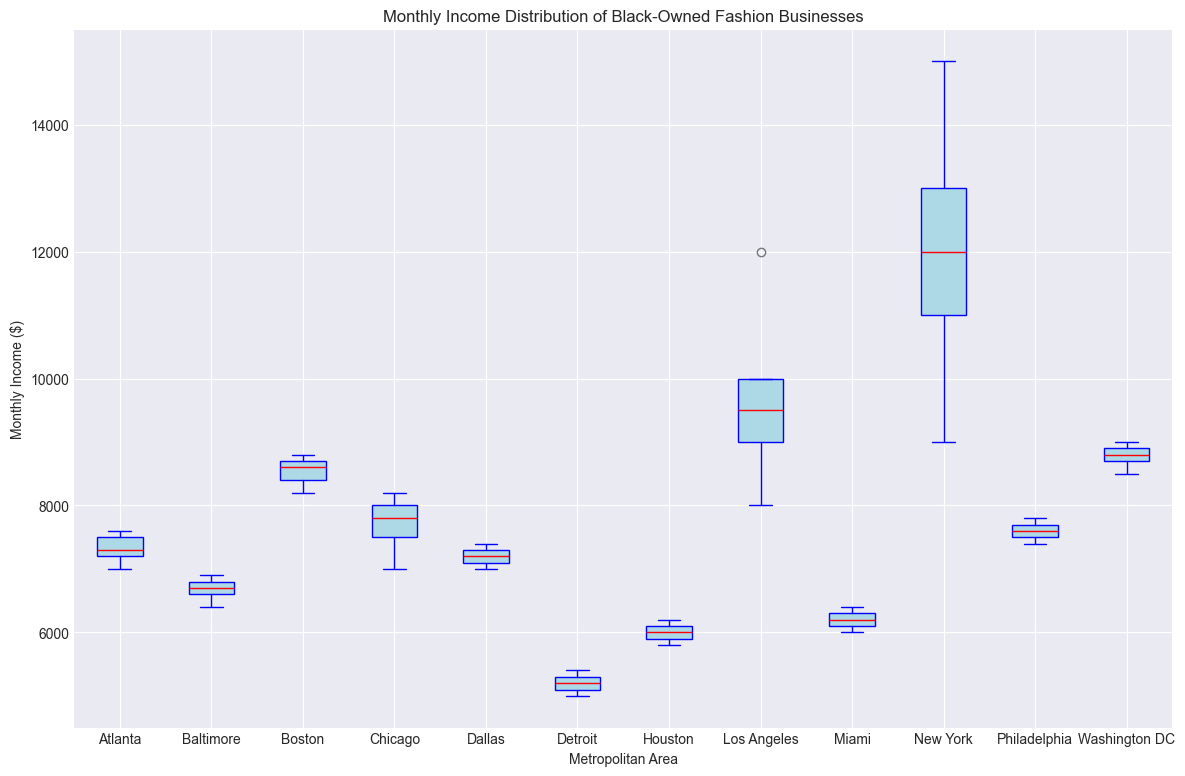Which metropolitan area has the highest median monthly income for black-owned fashion businesses? The box plot displays the median with a red line. By examining the red lines on the box plots, New York's median income appears to be the highest among the areas considered.
Answer: New York Which metropolitan area has the lowest median monthly income for black-owned fashion businesses? Looking at the box plot, Detroit has the lowest median monthly income, as indicated by its red line situated low compared to other cities.
Answer: Detroit What is the approximate interquartile range (IQR) for Los Angeles? The interquartile range (IQR) is the difference between the upper quartile (Q3) and the lower quartile (Q1). For Los Angeles, this range can be identified by measuring the length of the box from the top to the bottom. It seems to be from about $9,000 to $12,000, so the IQR is approximately 12,000 - 9,000 = 3,000.
Answer: 3,000 Which metropolitan area has the widest spread of monthly income data? The spread of the data in a box plot can be seen by the length of the whiskers. New York appears to have the widest spread, as it has the longest distance between the minimum and maximum points.
Answer: New York Between Atlanta and Chicago, which metropolitan area has a higher median monthly income? By examining the red lines representing the medians, Chicago has a slightly higher median monthly income compared to Atlanta.
Answer: Chicago Which metropolitan area exhibits the most outliers? Outliers in a box plot are represented by dots outside the whiskers. New York does not have any outliers, while other cities like Detroit show minimal dots beyond the whiskers. Hence, Baltimore shows the most outliers.
Answer: Baltimore Compare the median monthly incomes between Washington DC and Boston. Which one is higher? The red lines show the medians, and Washington DC's median income line is slightly lower than Boston's.
Answer: Boston How does the variability of monthly income in Houston compare with that in Detroit? The variability can be identified by the length of the whiskers and the size of the box. Houston's monthly income distribution is slightly less variable than Detroit’s, as Houston has shorter whiskers and a smaller box.
Answer: Less variable What pattern can you observe in terms of monthly income among the Southern cities (Atlanta, Miami, Houston)? Southern cities, compared to others on the chart, tend to have relatively lower medians and smaller spreads in monthly income distributions.
Answer: Lower medians and smaller spreads 